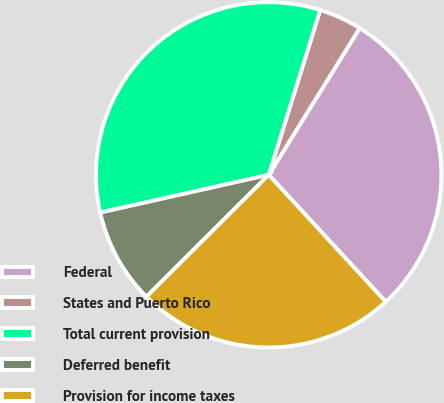Convert chart to OTSL. <chart><loc_0><loc_0><loc_500><loc_500><pie_chart><fcel>Federal<fcel>States and Puerto Rico<fcel>Total current provision<fcel>Deferred benefit<fcel>Provision for income taxes<nl><fcel>29.31%<fcel>4.02%<fcel>33.33%<fcel>8.96%<fcel>24.38%<nl></chart> 